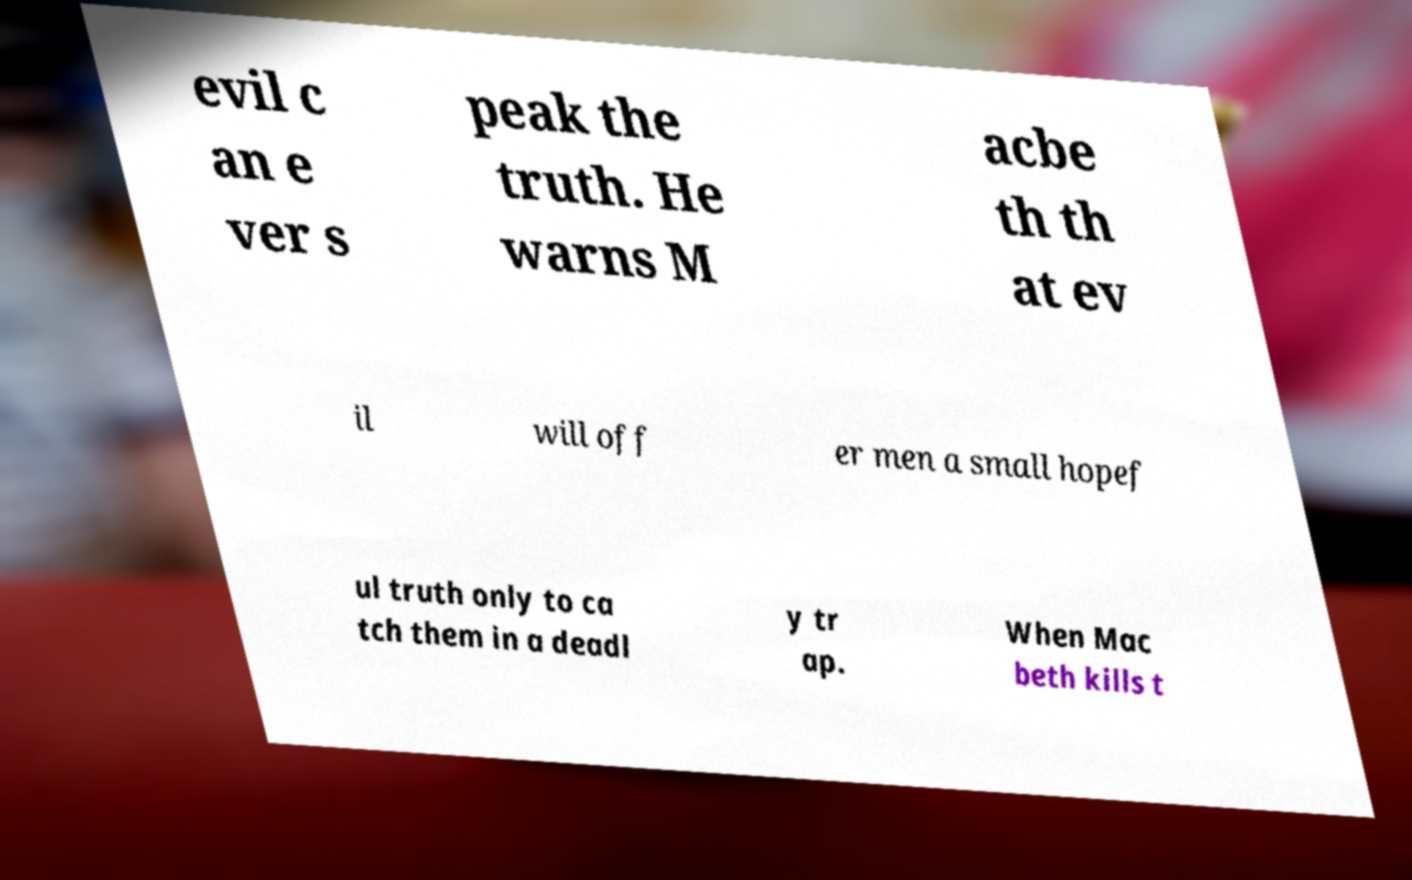I need the written content from this picture converted into text. Can you do that? evil c an e ver s peak the truth. He warns M acbe th th at ev il will off er men a small hopef ul truth only to ca tch them in a deadl y tr ap. When Mac beth kills t 